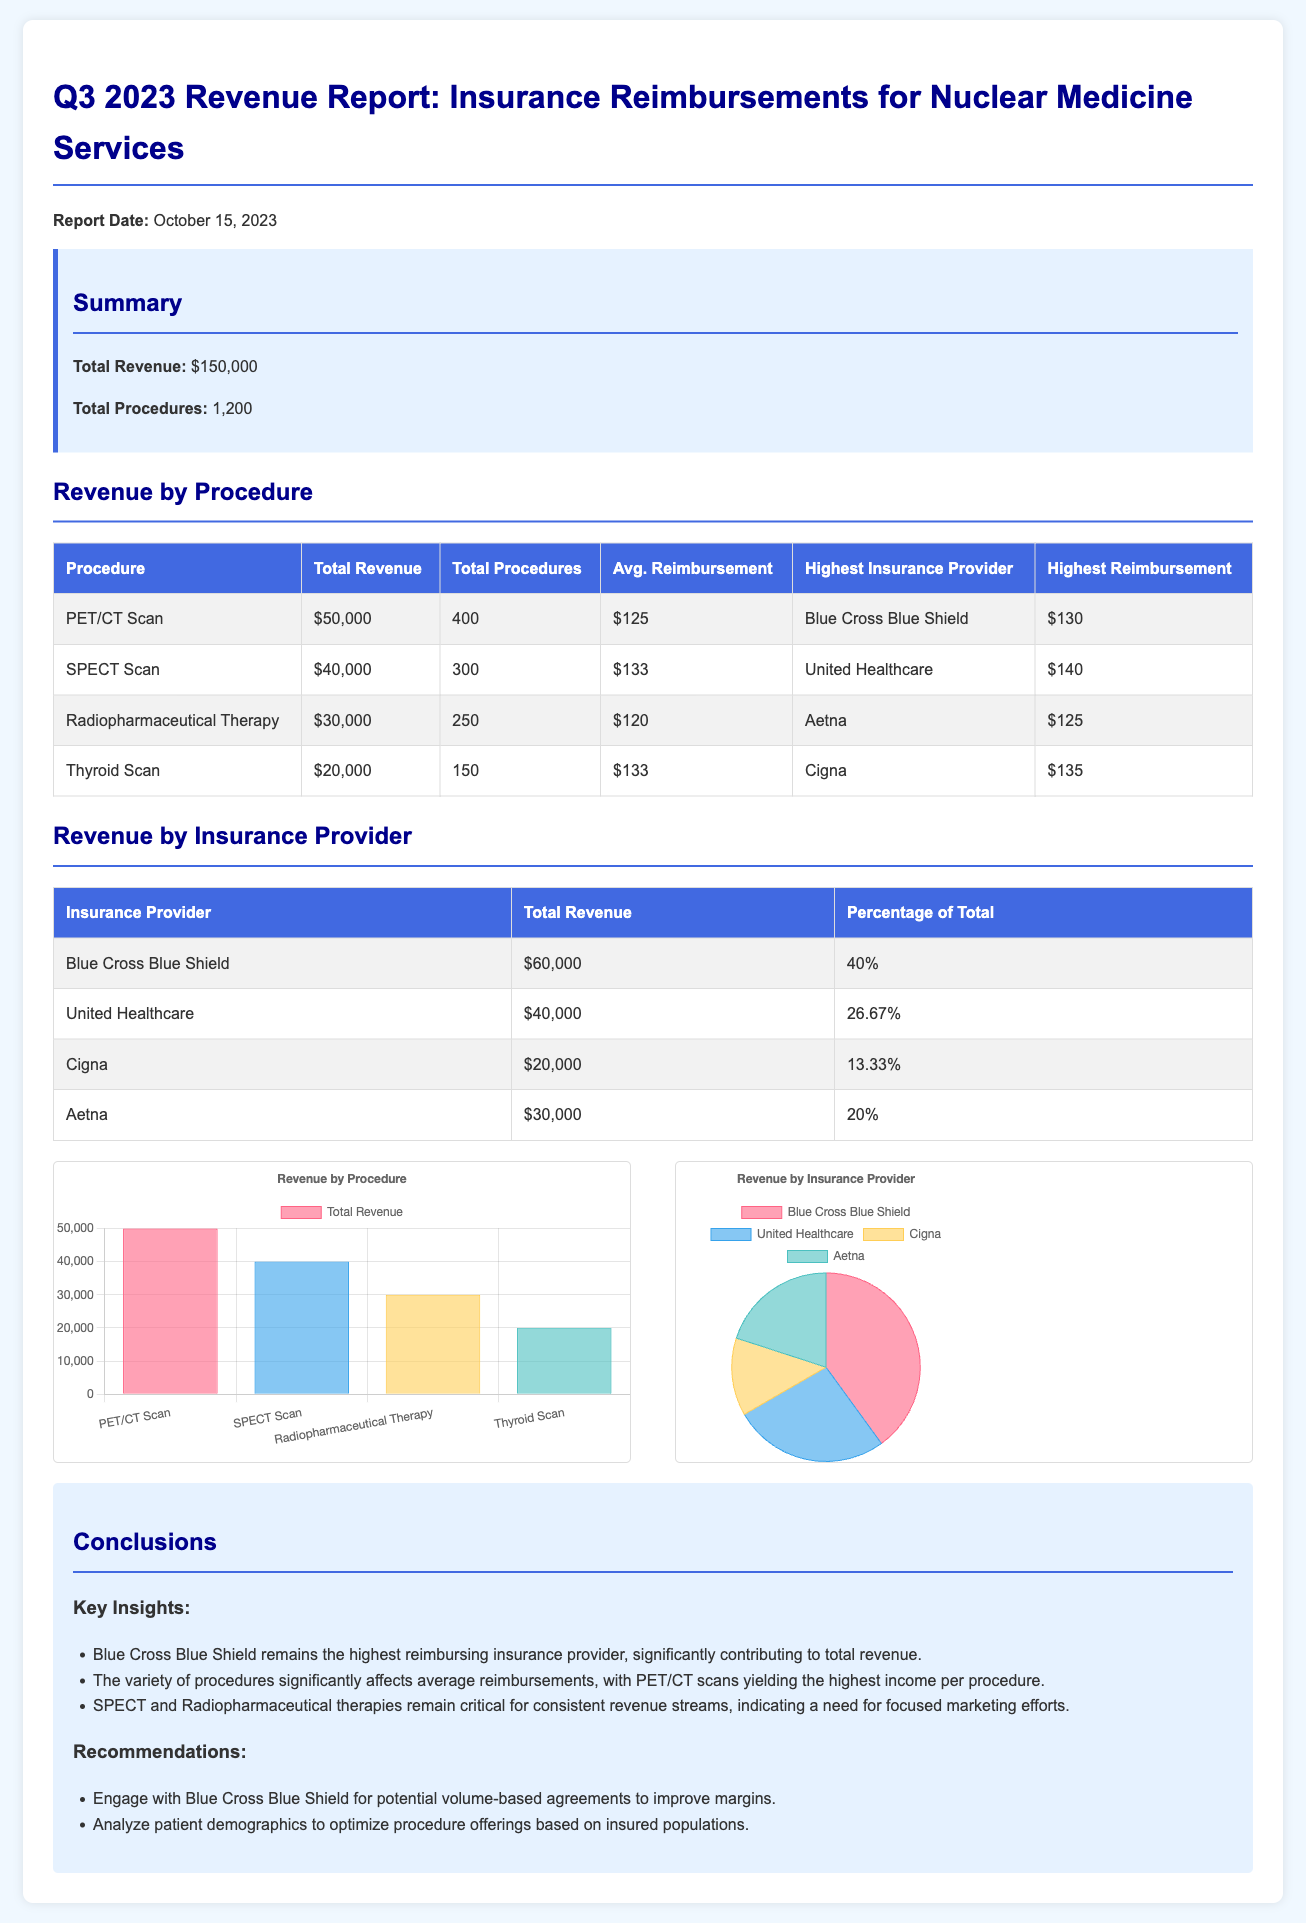What is the total revenue? The total revenue is explicitly stated in the summary section of the report, which amounts to $150,000.
Answer: $150,000 How many total procedures were conducted? The number of total procedures is provided in the summary section as well, which is 1,200.
Answer: 1,200 Which procedure generated the highest total revenue? The procedure with the highest total revenue is listed in the revenue by procedure table, which is the PET/CT Scan with $50,000.
Answer: PET/CT Scan What is the average reimbursement for the SPECT Scan? The average reimbursement for the SPECT Scan is explicitly mentioned in the revenue by procedure table as $133.
Answer: $133 What percentage of the total revenue does Blue Cross Blue Shield account for? The percentage is given in the revenue by insurance provider table, showing that Blue Cross Blue Shield accounts for 40% of the total revenue.
Answer: 40% Which insurance provider reimbursed the highest amount for the Radiopharmaceutical Therapy? The highest reimbursement for Radiopharmaceutical Therapy is from Aetna, as noted in the revenue by procedure table with $125.
Answer: Aetna What is the total revenue from United Healthcare? The total revenue from United Healthcare is listed in the revenue by insurance provider table as $40,000.
Answer: $40,000 Name one recommendation from the conclusions section. The conclusions section lists recommendations, one of which is to engage with Blue Cross Blue Shield for potential volume-based agreements.
Answer: Engage with Blue Cross Blue Shield How many procedures were performed for the Thyroid Scan? The total procedures for the Thyroid Scan is specifically noted in the revenue by procedure table as 150.
Answer: 150 